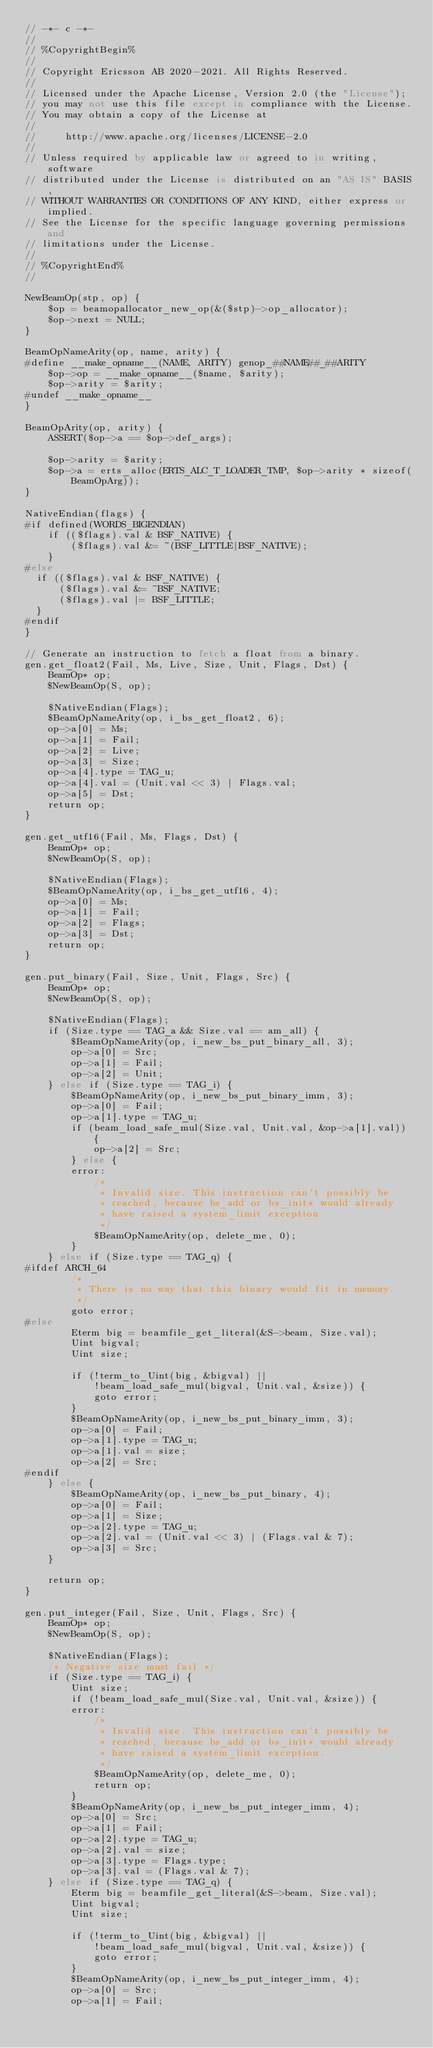<code> <loc_0><loc_0><loc_500><loc_500><_SQL_>// -*- c -*-
//
// %CopyrightBegin%
//
// Copyright Ericsson AB 2020-2021. All Rights Reserved.
//
// Licensed under the Apache License, Version 2.0 (the "License");
// you may not use this file except in compliance with the License.
// You may obtain a copy of the License at
//
//     http://www.apache.org/licenses/LICENSE-2.0
//
// Unless required by applicable law or agreed to in writing, software
// distributed under the License is distributed on an "AS IS" BASIS,
// WITHOUT WARRANTIES OR CONDITIONS OF ANY KIND, either express or implied.
// See the License for the specific language governing permissions and
// limitations under the License.
//
// %CopyrightEnd%
//

NewBeamOp(stp, op) {
    $op = beamopallocator_new_op(&($stp)->op_allocator);
    $op->next = NULL;
}

BeamOpNameArity(op, name, arity) {
#define __make_opname__(NAME, ARITY) genop_##NAME##_##ARITY
    $op->op = __make_opname__($name, $arity);
    $op->arity = $arity;
#undef __make_opname__
}

BeamOpArity(op, arity) {
    ASSERT($op->a == $op->def_args);

    $op->arity = $arity;
    $op->a = erts_alloc(ERTS_ALC_T_LOADER_TMP, $op->arity * sizeof(BeamOpArg));
}

NativeEndian(flags) {
#if defined(WORDS_BIGENDIAN)
    if (($flags).val & BSF_NATIVE) {
        ($flags).val &= ~(BSF_LITTLE|BSF_NATIVE);
    }
#else
  if (($flags).val & BSF_NATIVE) {
      ($flags).val &= ~BSF_NATIVE;
      ($flags).val |= BSF_LITTLE;
  }
#endif
}

// Generate an instruction to fetch a float from a binary.
gen.get_float2(Fail, Ms, Live, Size, Unit, Flags, Dst) {
    BeamOp* op;
    $NewBeamOp(S, op);

    $NativeEndian(Flags);
    $BeamOpNameArity(op, i_bs_get_float2, 6);
    op->a[0] = Ms;
    op->a[1] = Fail;
    op->a[2] = Live;
    op->a[3] = Size;
    op->a[4].type = TAG_u;
    op->a[4].val = (Unit.val << 3) | Flags.val;
    op->a[5] = Dst;
    return op;
}

gen.get_utf16(Fail, Ms, Flags, Dst) {
    BeamOp* op;
    $NewBeamOp(S, op);

    $NativeEndian(Flags);
    $BeamOpNameArity(op, i_bs_get_utf16, 4);
    op->a[0] = Ms;
    op->a[1] = Fail;
    op->a[2] = Flags;
    op->a[3] = Dst;
    return op;
}

gen.put_binary(Fail, Size, Unit, Flags, Src) {
    BeamOp* op;
    $NewBeamOp(S, op);

    $NativeEndian(Flags);
    if (Size.type == TAG_a && Size.val == am_all) {
        $BeamOpNameArity(op, i_new_bs_put_binary_all, 3);
        op->a[0] = Src;
        op->a[1] = Fail;
        op->a[2] = Unit;
    } else if (Size.type == TAG_i) {
        $BeamOpNameArity(op, i_new_bs_put_binary_imm, 3);
        op->a[0] = Fail;
        op->a[1].type = TAG_u;
        if (beam_load_safe_mul(Size.val, Unit.val, &op->a[1].val)) {
            op->a[2] = Src;
        } else {
        error:
            /*
             * Invalid size. This instruction can't possibly be
             * reached, because bs_add or bs_init* would already
             * have raised a system_limit exception.
             */
            $BeamOpNameArity(op, delete_me, 0);
        }
    } else if (Size.type == TAG_q) {
#ifdef ARCH_64
        /*
         * There is no way that this binary would fit in memory.
         */
        goto error;
#else
        Eterm big = beamfile_get_literal(&S->beam, Size.val);
        Uint bigval;
        Uint size;

        if (!term_to_Uint(big, &bigval) ||
            !beam_load_safe_mul(bigval, Unit.val, &size)) {
            goto error;
        }
        $BeamOpNameArity(op, i_new_bs_put_binary_imm, 3);
        op->a[0] = Fail;
        op->a[1].type = TAG_u;
        op->a[1].val = size;
        op->a[2] = Src;
#endif
    } else {
        $BeamOpNameArity(op, i_new_bs_put_binary, 4);
        op->a[0] = Fail;
        op->a[1] = Size;
        op->a[2].type = TAG_u;
        op->a[2].val = (Unit.val << 3) | (Flags.val & 7);
        op->a[3] = Src;
    }

    return op;
}

gen.put_integer(Fail, Size, Unit, Flags, Src) {
    BeamOp* op;
    $NewBeamOp(S, op);

    $NativeEndian(Flags);
    /* Negative size must fail */
    if (Size.type == TAG_i) {
        Uint size;
        if (!beam_load_safe_mul(Size.val, Unit.val, &size)) {
        error:
            /*
             * Invalid size. This instruction can't possibly be
             * reached, because bs_add or bs_init* would already
             * have raised a system_limit exception.
             */
            $BeamOpNameArity(op, delete_me, 0);
            return op;
        }
        $BeamOpNameArity(op, i_new_bs_put_integer_imm, 4);
        op->a[0] = Src;
        op->a[1] = Fail;
        op->a[2].type = TAG_u;
        op->a[2].val = size;
        op->a[3].type = Flags.type;
        op->a[3].val = (Flags.val & 7);
    } else if (Size.type == TAG_q) {
        Eterm big = beamfile_get_literal(&S->beam, Size.val);
        Uint bigval;
        Uint size;

        if (!term_to_Uint(big, &bigval) ||
            !beam_load_safe_mul(bigval, Unit.val, &size)) {
            goto error;
        }
        $BeamOpNameArity(op, i_new_bs_put_integer_imm, 4);
        op->a[0] = Src;
        op->a[1] = Fail;</code> 